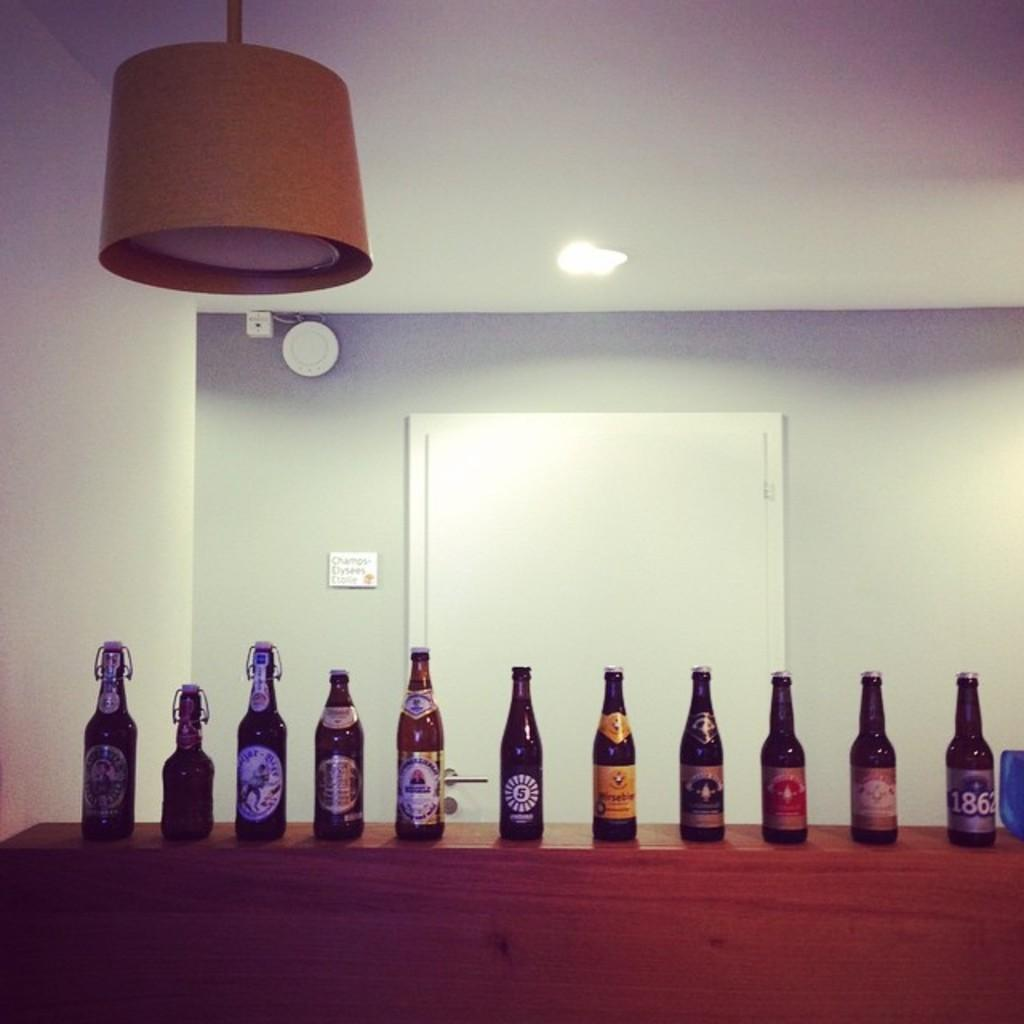Provide a one-sentence caption for the provided image. Several bottles of beer are neatly lined up n a shelf, the one on the far end has 1862 on the label. 